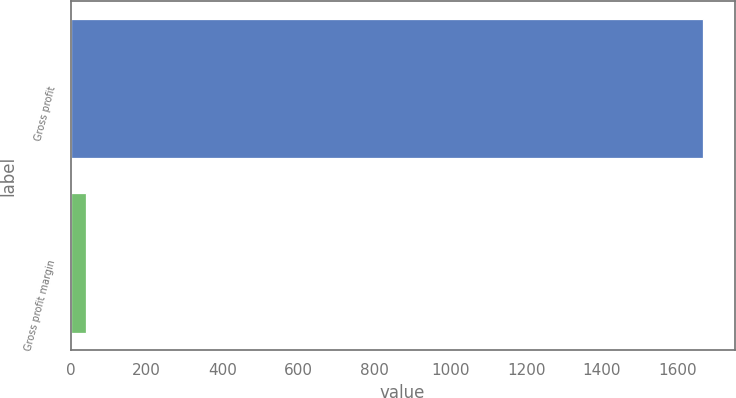Convert chart to OTSL. <chart><loc_0><loc_0><loc_500><loc_500><bar_chart><fcel>Gross profit<fcel>Gross profit margin<nl><fcel>1665.8<fcel>40.4<nl></chart> 